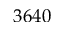Convert formula to latex. <formula><loc_0><loc_0><loc_500><loc_500>3 6 4 0</formula> 